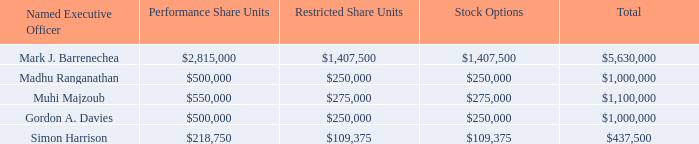Fiscal 2021 LTIP
Grants made in Fiscal 2019 under the Fiscal 2021 LTIP took effect on August 6, 2018 with the goal of measuring performance over the three year period starting July 1, 2018. The table below illustrates the target value of each element under the Fiscal 2021 LTIP for each Named Executive Officer.
Awards granted in Fiscal 2019 under the Fiscal 2021 LTIP were in addition to the awards granted in Fiscal 2018, Fiscal 2017, and prior years. For details of our previous LTIPs, see Item 11 of our Annual Report on Form 10-K for the appropriate year.
What does the table represent? Illustrates the target value of each element under the fiscal 2021 ltip for each named executive officer. Who are the Named Executive Officers? Mark j. barrenechea, madhu ranganathan, muhi majzoub, gordon a. davies, simon harrison. What is the total target value for Mark J. Barrenechea? 5,630,000. What is the average total target value for all Named Executive Officers? (5,630,000+1,000,000+1,100,000+1,000,000+437,500)/5
Answer: 1833500. What is Mark J. Barrenechea's Total target value expressed as percentage of total target values for all Named Executive Officer?
Answer scale should be: percent. 5,630,000/(5,630,000+1,000,000+1,100,000+1,000,000+437,500)
Answer: 61.41. What is Simon Harrison's Total target value expressed as percentage of total target values for all Named Executive Officer?
Answer scale should be: percent. 437,500/(5,630,000+1,000,000+1,100,000+1,000,000+437,500)
Answer: 4.77. 